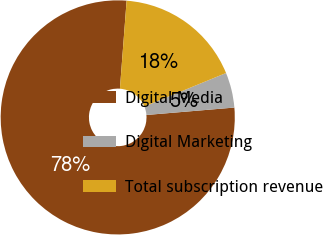Convert chart. <chart><loc_0><loc_0><loc_500><loc_500><pie_chart><fcel>Digital Media<fcel>Digital Marketing<fcel>Total subscription revenue<nl><fcel>77.55%<fcel>4.85%<fcel>17.6%<nl></chart> 